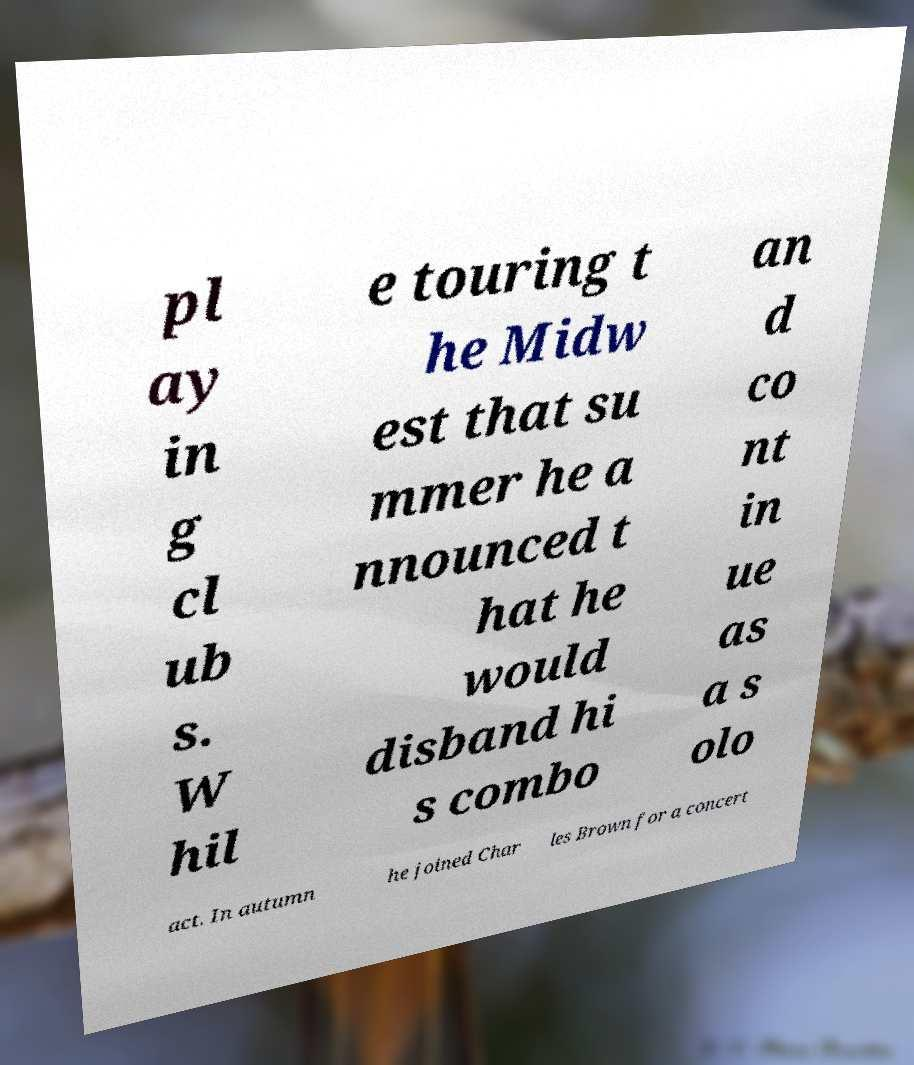Please identify and transcribe the text found in this image. pl ay in g cl ub s. W hil e touring t he Midw est that su mmer he a nnounced t hat he would disband hi s combo an d co nt in ue as a s olo act. In autumn he joined Char les Brown for a concert 